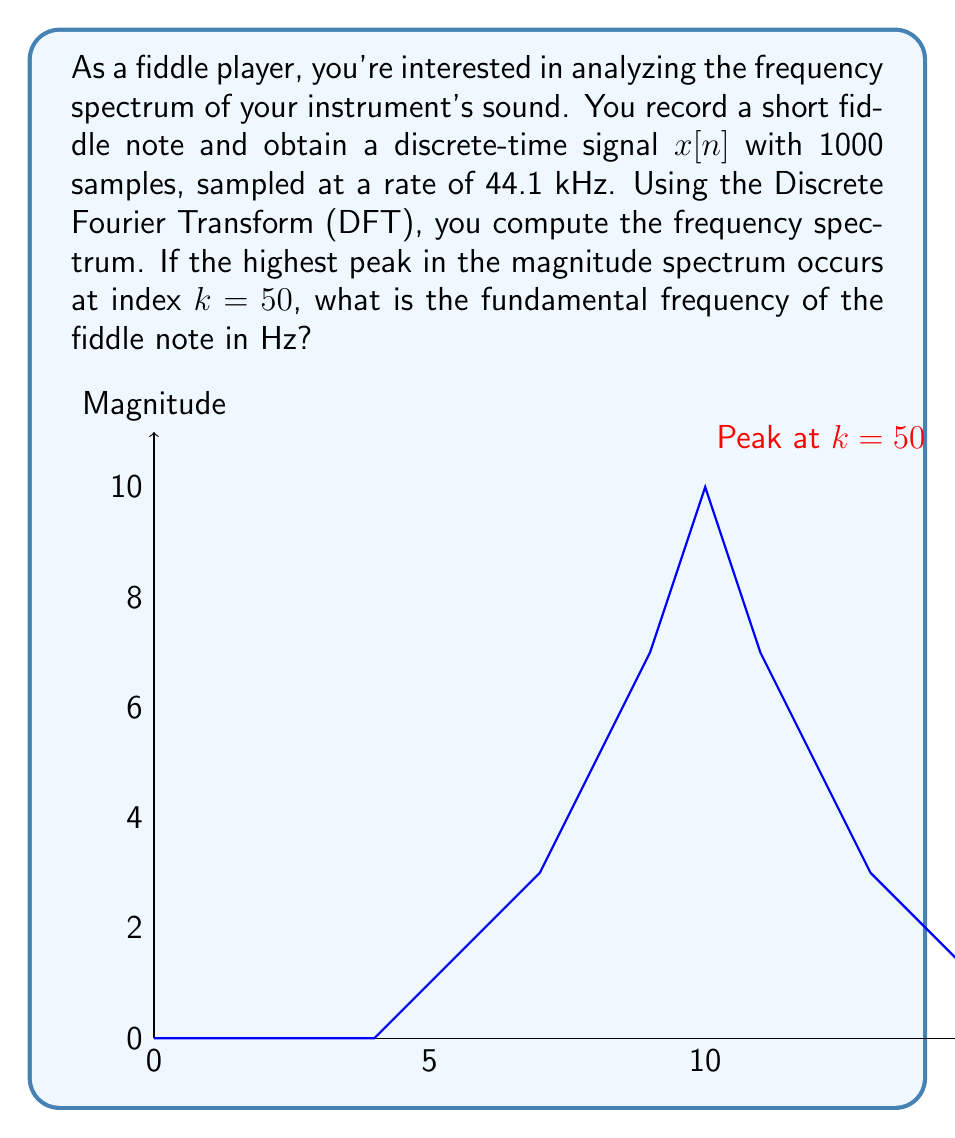Solve this math problem. Let's approach this step-by-step:

1) The Discrete Fourier Transform (DFT) of a signal with $N$ samples results in $N$ frequency bins.

2) The frequency resolution of the DFT is given by:

   $$\Delta f = \frac{f_s}{N}$$

   where $f_s$ is the sampling frequency and $N$ is the number of samples.

3) In this case:
   $f_s = 44.1$ kHz $= 44100$ Hz
   $N = 1000$ samples

4) Calculating the frequency resolution:

   $$\Delta f = \frac{44100}{1000} = 44.1 \text{ Hz}$$

5) The frequency corresponding to the $k$-th bin is given by:

   $$f_k = k \cdot \Delta f$$

6) The highest peak occurs at $k = 50$, so the fundamental frequency is:

   $$f_{fundamental} = 50 \cdot 44.1 = 2205 \text{ Hz}$$

Therefore, the fundamental frequency of the fiddle note is 2205 Hz.
Answer: 2205 Hz 